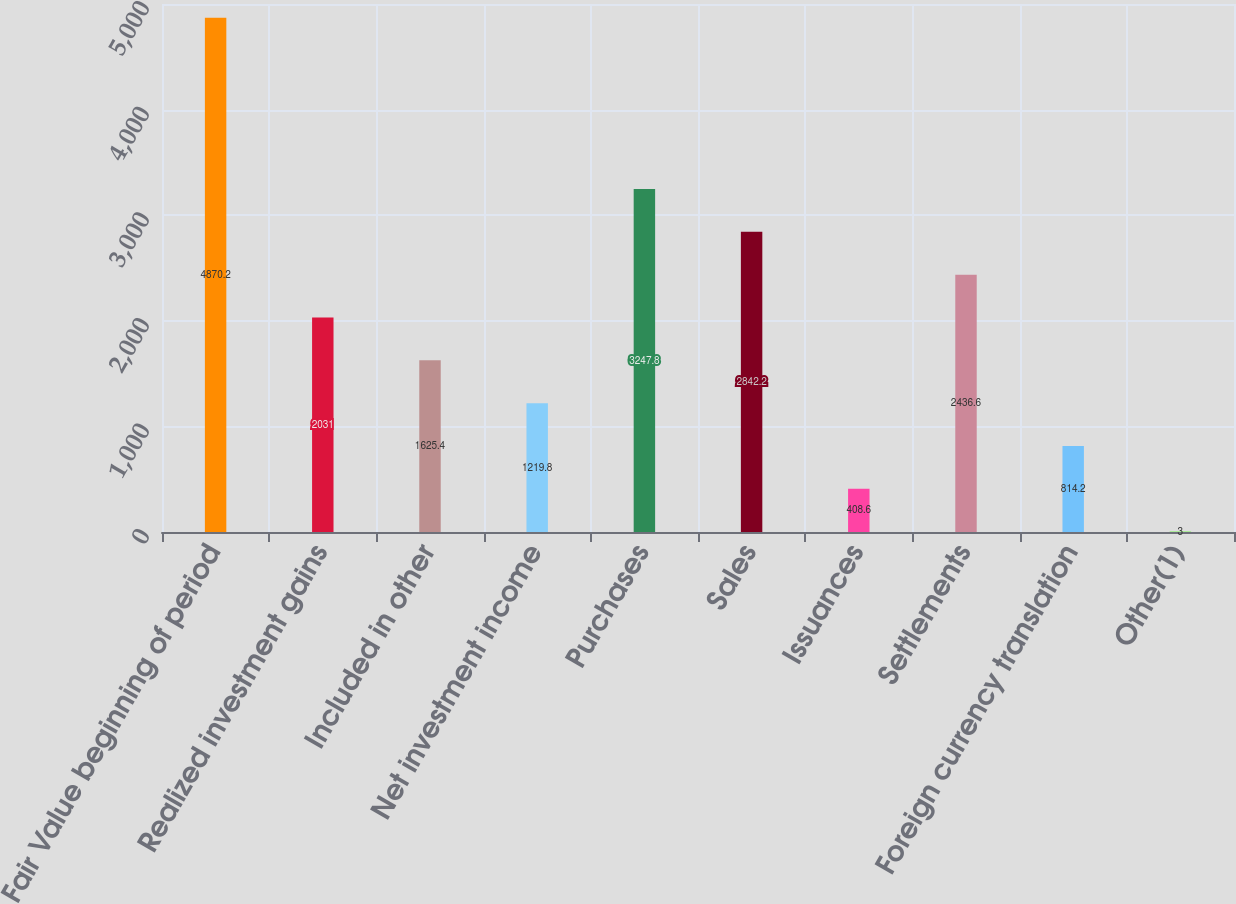Convert chart. <chart><loc_0><loc_0><loc_500><loc_500><bar_chart><fcel>Fair Value beginning of period<fcel>Realized investment gains<fcel>Included in other<fcel>Net investment income<fcel>Purchases<fcel>Sales<fcel>Issuances<fcel>Settlements<fcel>Foreign currency translation<fcel>Other(1)<nl><fcel>4870.2<fcel>2031<fcel>1625.4<fcel>1219.8<fcel>3247.8<fcel>2842.2<fcel>408.6<fcel>2436.6<fcel>814.2<fcel>3<nl></chart> 